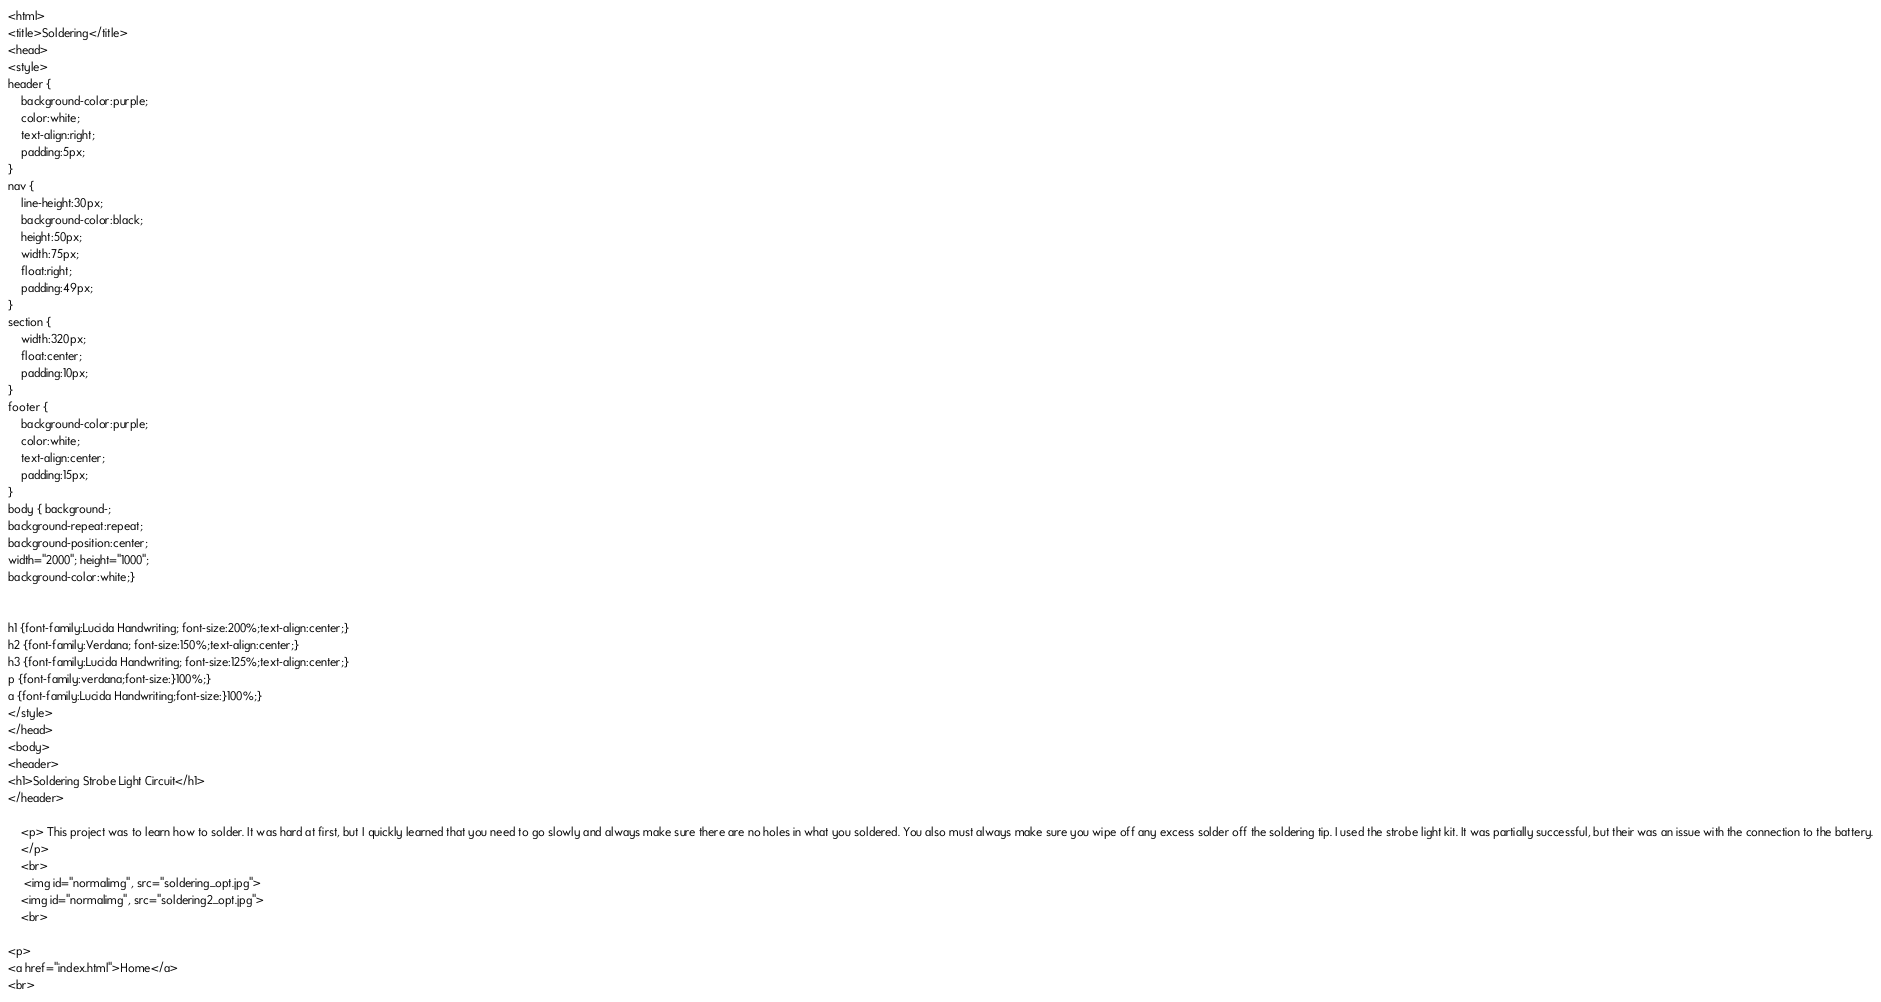<code> <loc_0><loc_0><loc_500><loc_500><_HTML_><html>
<title>Soldering</title>
<head>
<style>
header {
    background-color:purple;
    color:white;
    text-align:right;
    padding:5px;	 
}
nav {
    line-height:30px;
    background-color:black;
    height:50px;
    width:75px;
    float:right;
    padding:49px;	   
}
section {
    width:320px;
    float:center;
    padding:10px;	 	 
}
footer {
    background-color:purple;
    color:white;
    text-align:center;
    padding:15px;	
}
body { background-;
background-repeat:repeat;
background-position:center;
width="2000"; height="1000";
background-color:white;}


h1 {font-family:Lucida Handwriting; font-size:200%;text-align:center;}
h2 {font-family:Verdana; font-size:150%;text-align:center;}
h3 {font-family:Lucida Handwriting; font-size:125%;text-align:center;}
p {font-family:verdana;font-size:}100%;}
a {font-family:Lucida Handwriting;font-size:}100%;}
</style>
</head>
<body>
<header>
<h1>Soldering Strobe Light Circuit</h1>
</header>
    
    <p> This project was to learn how to solder. It was hard at first, but I quickly learned that you need to go slowly and always make sure there are no holes in what you soldered. You also must always make sure you wipe off any excess solder off the soldering tip. I used the strobe light kit. It was partially successful, but their was an issue with the connection to the battery.
    </p>
    <br>
     <img id="normalimg", src="soldering_opt.jpg">
    <img id="normalimg", src="soldering2_opt.jpg">
    <br>
  
<p>
<a href="index.html">Home</a>
<br>
</code> 